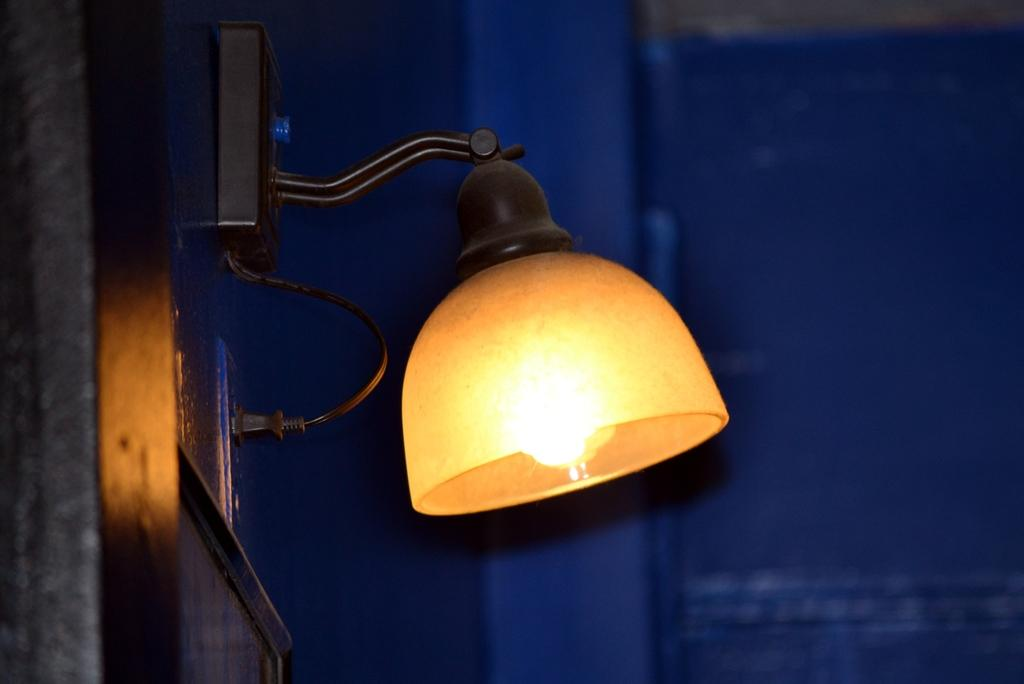What object is attached to the wall in the image? There is a lamp in the image, and it is placed on the wall. On which side of the image is the lamp located? The lamp is on the left side of the image. Can you see a woman performing magic under the moon in the image? No, there is no woman, magic, or moon present in the image. The image only features a lamp placed on the wall. 